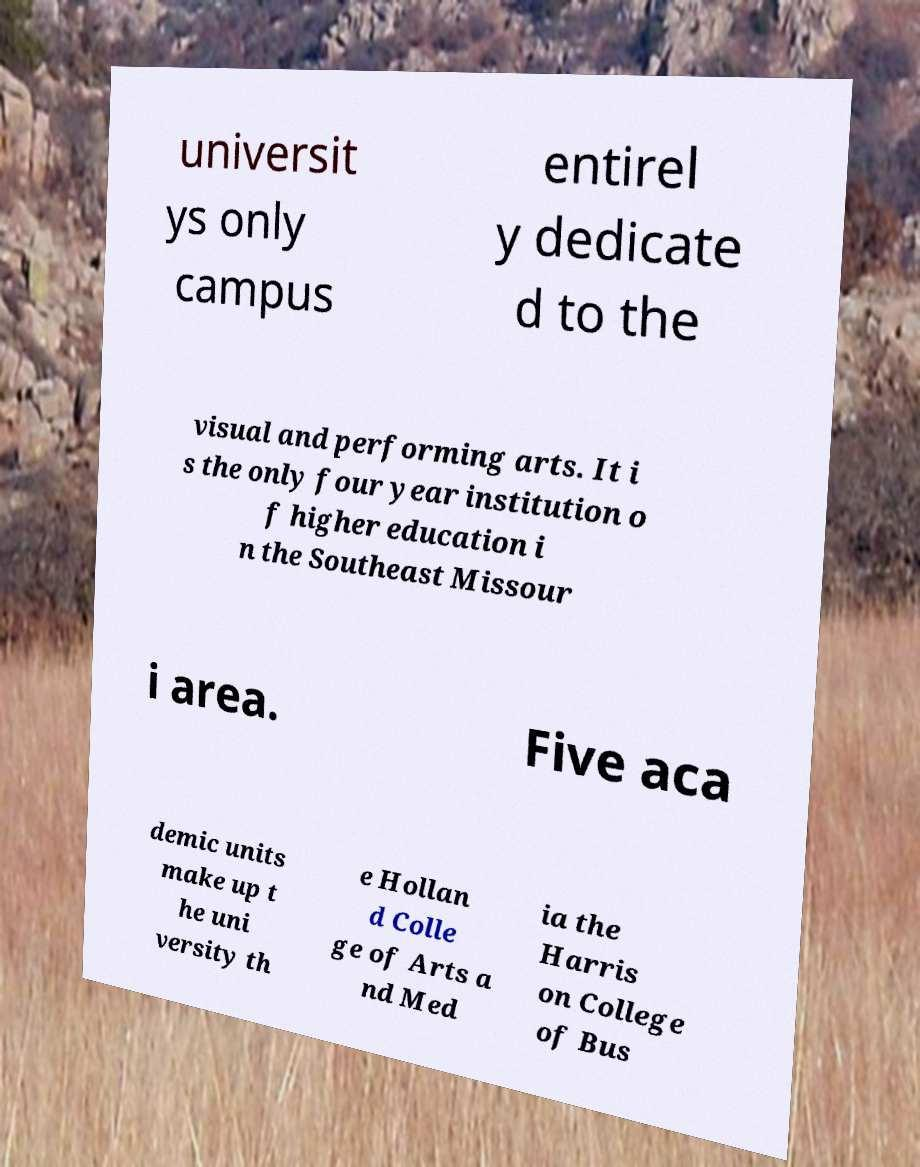There's text embedded in this image that I need extracted. Can you transcribe it verbatim? universit ys only campus entirel y dedicate d to the visual and performing arts. It i s the only four year institution o f higher education i n the Southeast Missour i area. Five aca demic units make up t he uni versity th e Hollan d Colle ge of Arts a nd Med ia the Harris on College of Bus 